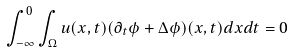Convert formula to latex. <formula><loc_0><loc_0><loc_500><loc_500>\int _ { - \infty } ^ { 0 } \int _ { \Omega } u ( x , t ) ( \partial _ { t } \phi + \Delta \phi ) ( x , t ) d x d t = 0</formula> 